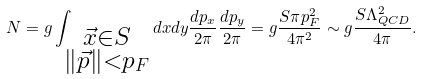<formula> <loc_0><loc_0><loc_500><loc_500>N = g \int _ { \substack { \vec { x } \in S \\ \| { \vec { p } } \| < p _ { F } } } d { x } d { y } \frac { d { p _ { x } } } { 2 \pi } \frac { d { p _ { y } } } { 2 \pi } = g \frac { S \pi p _ { F } ^ { 2 } } { 4 \pi ^ { 2 } } \sim g \frac { S \Lambda _ { Q C D } ^ { 2 } } { 4 \pi } .</formula> 